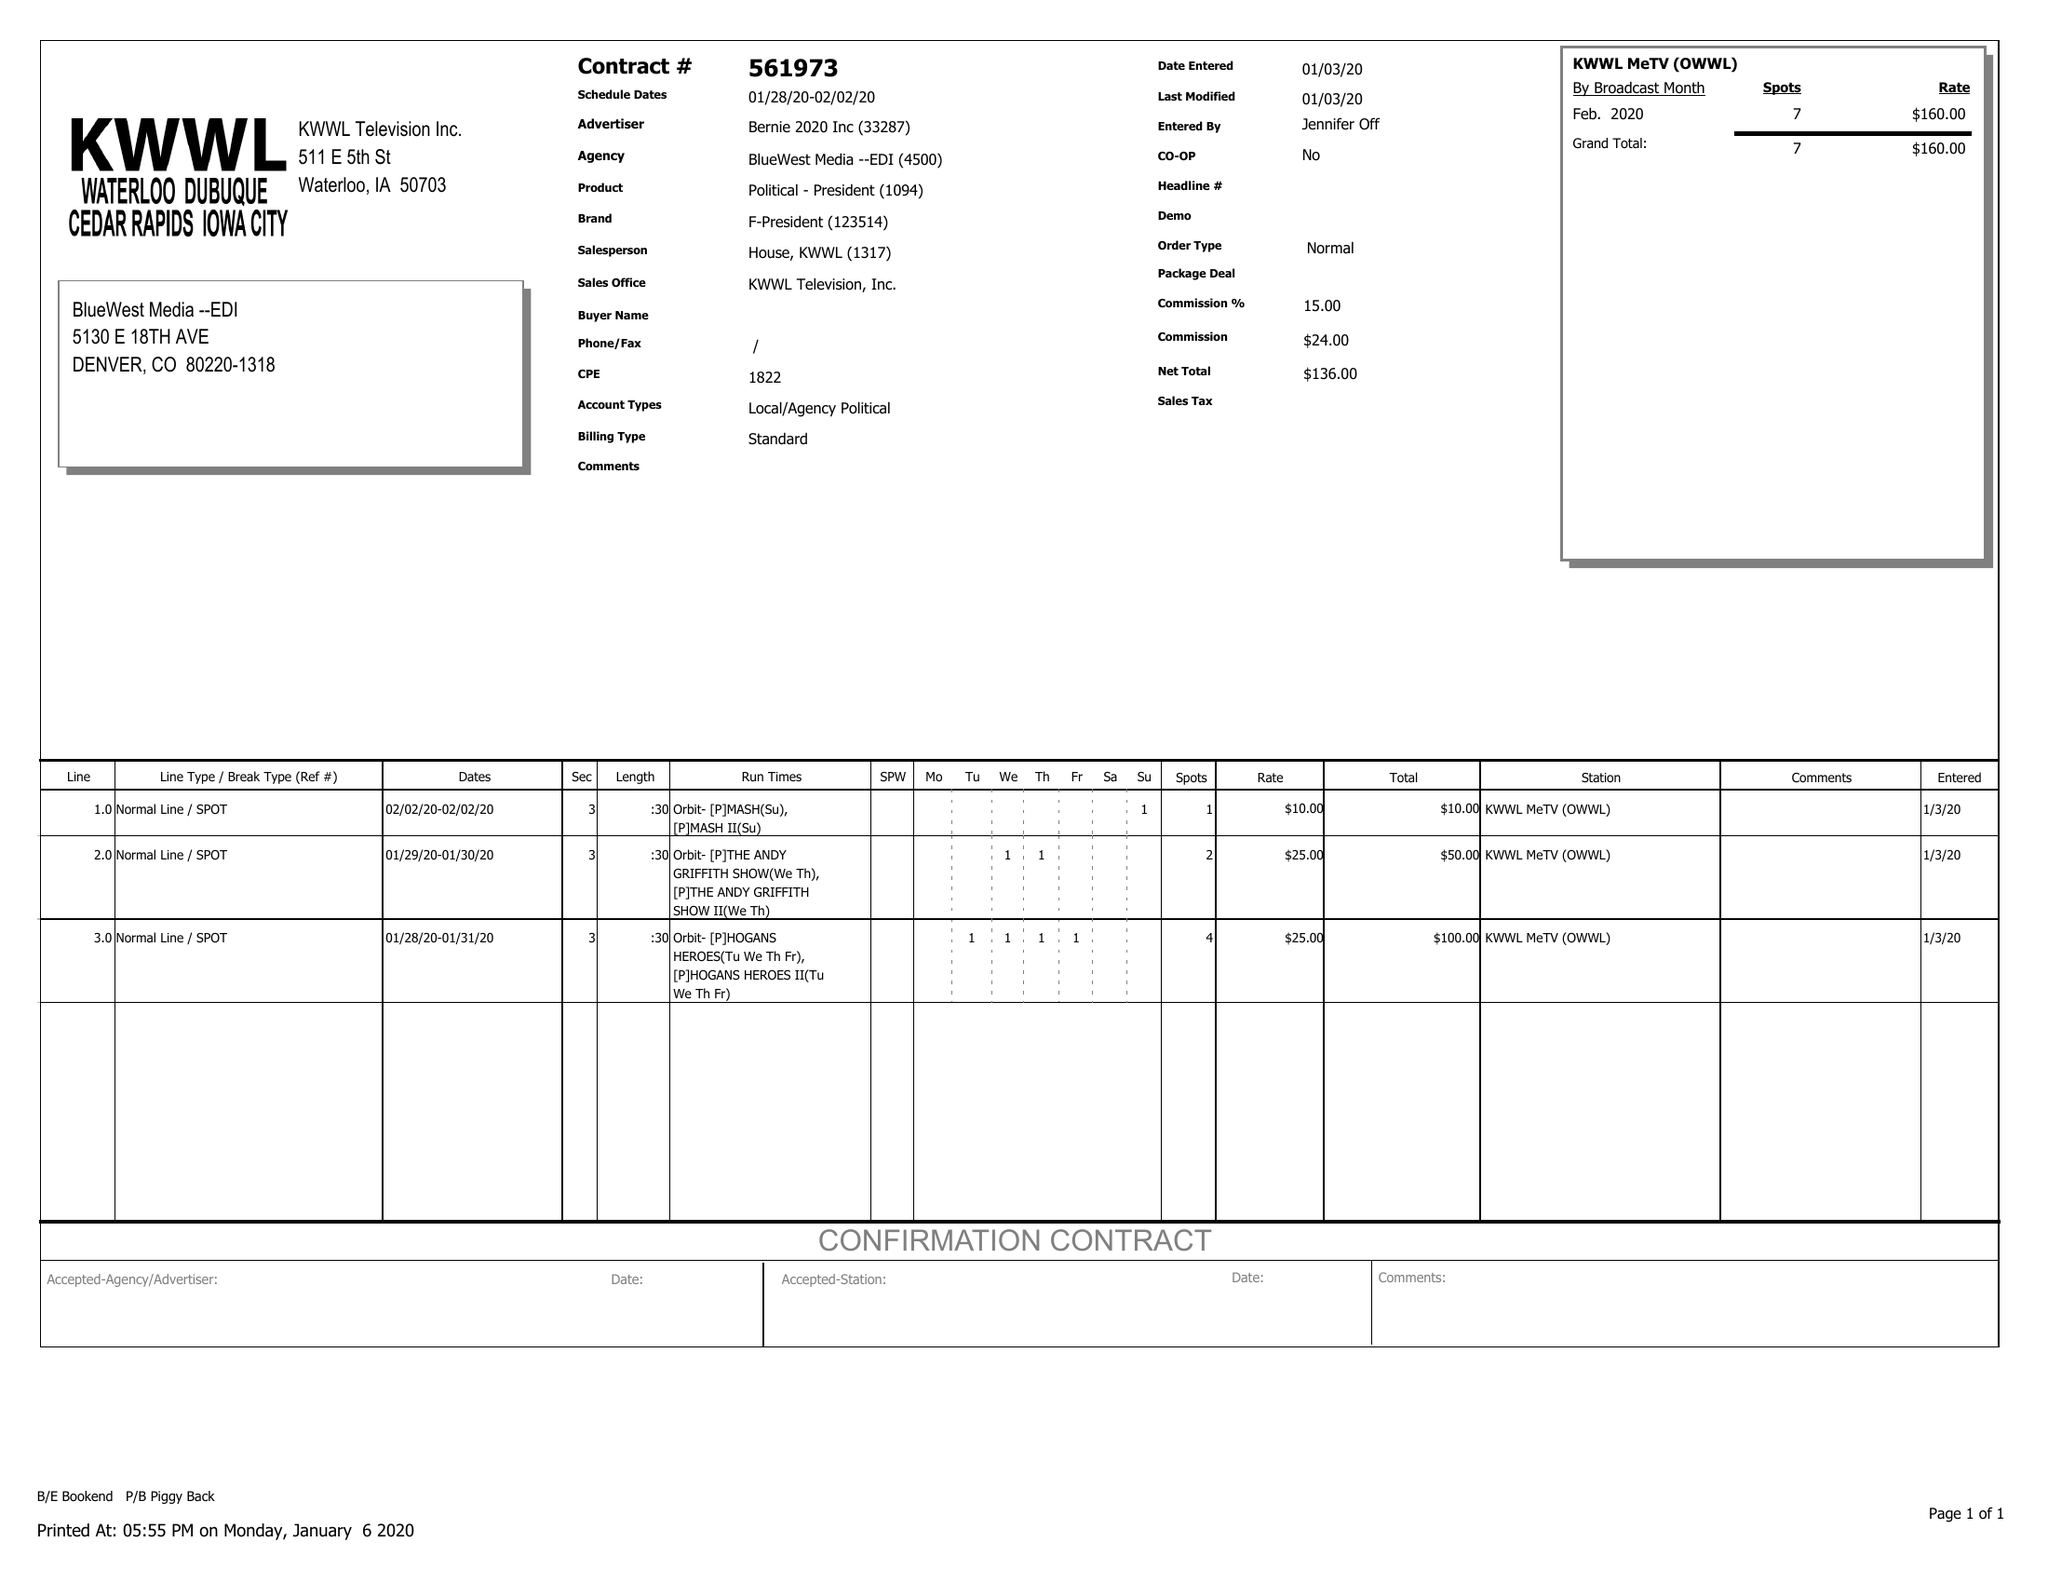What is the value for the flight_from?
Answer the question using a single word or phrase. 01/28/20 